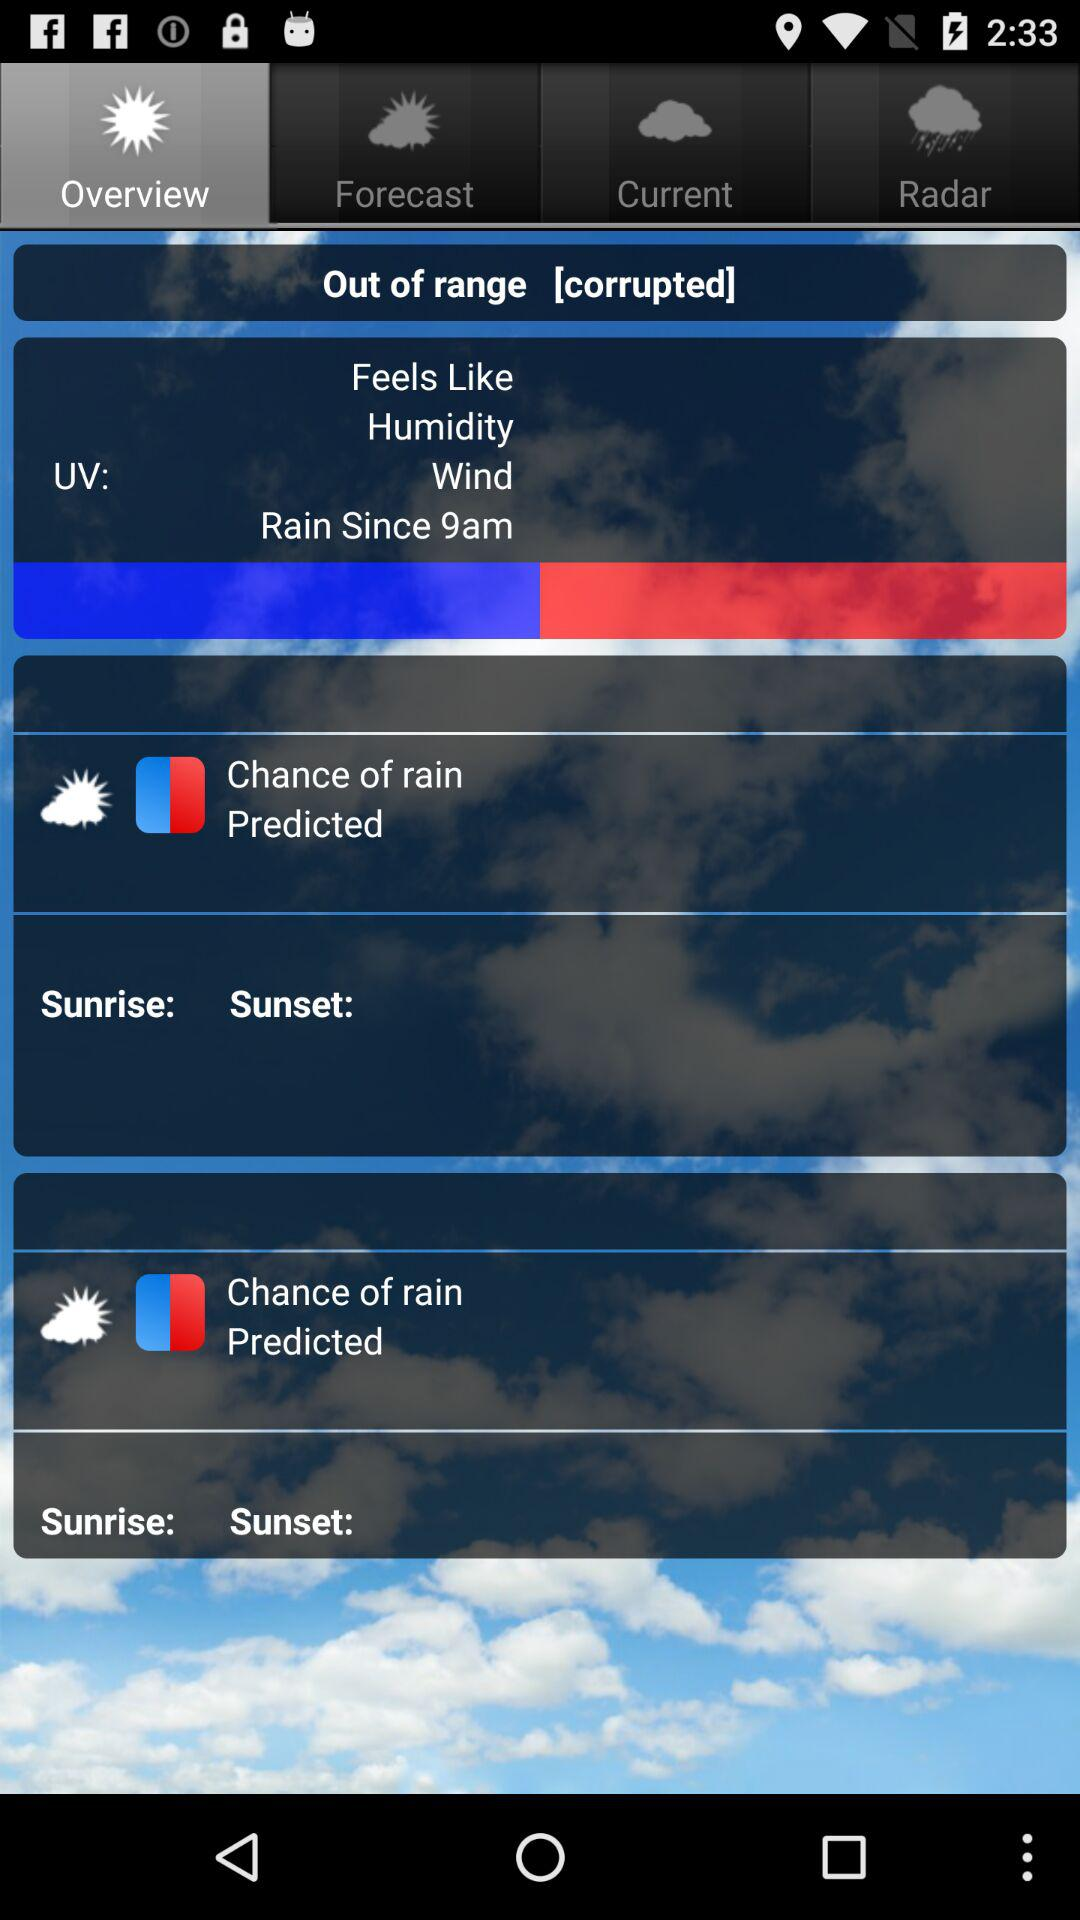Which tab is selected? The selected tab is "Overview". 